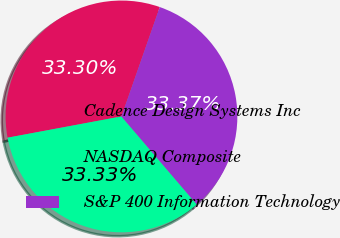Convert chart to OTSL. <chart><loc_0><loc_0><loc_500><loc_500><pie_chart><fcel>Cadence Design Systems Inc<fcel>NASDAQ Composite<fcel>S&P 400 Information Technology<nl><fcel>33.3%<fcel>33.33%<fcel>33.37%<nl></chart> 